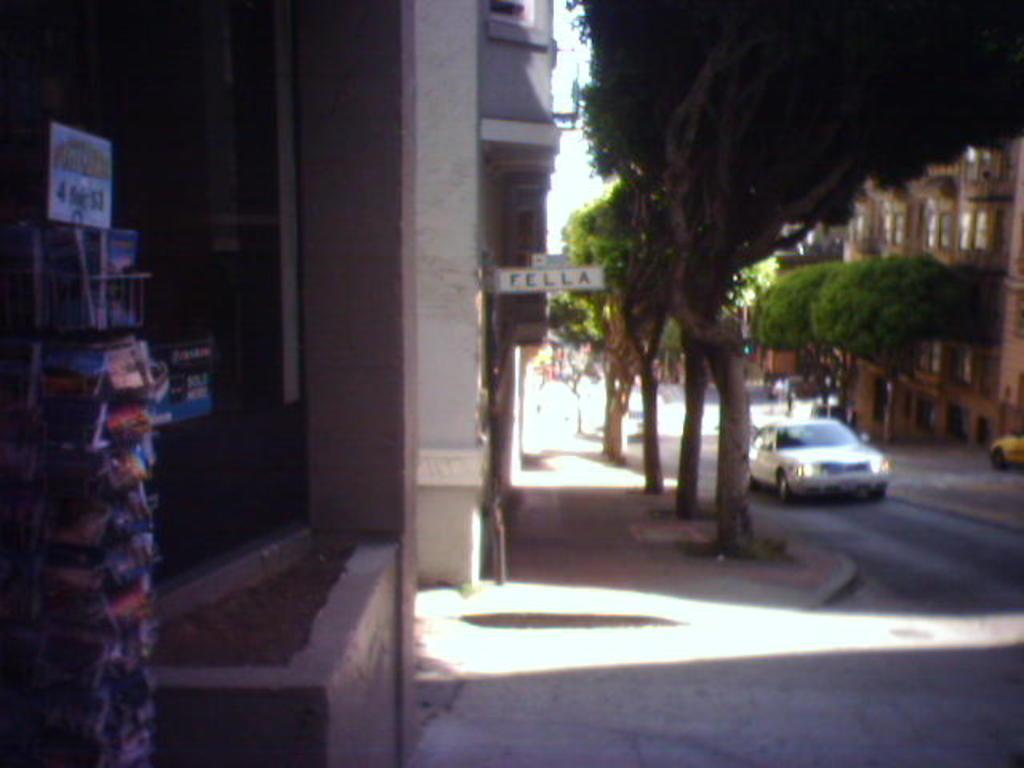Describe this image in one or two sentences. In this image I can see few vehicles on the road. I can also see a building in white color, trees in green color and sky in white color, in front I can see the other building in brown color. 